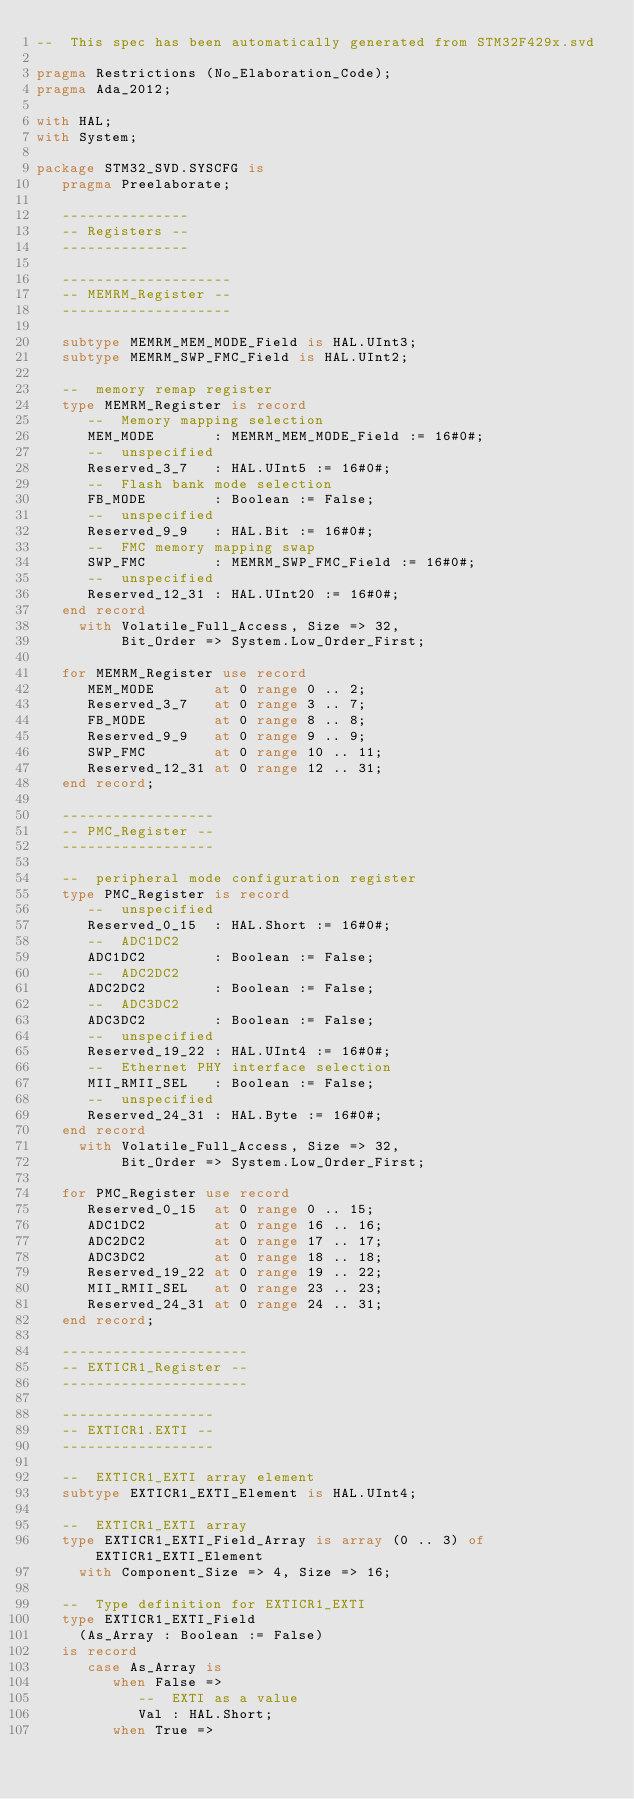Convert code to text. <code><loc_0><loc_0><loc_500><loc_500><_Ada_>--  This spec has been automatically generated from STM32F429x.svd

pragma Restrictions (No_Elaboration_Code);
pragma Ada_2012;

with HAL;
with System;

package STM32_SVD.SYSCFG is
   pragma Preelaborate;

   ---------------
   -- Registers --
   ---------------

   --------------------
   -- MEMRM_Register --
   --------------------

   subtype MEMRM_MEM_MODE_Field is HAL.UInt3;
   subtype MEMRM_SWP_FMC_Field is HAL.UInt2;

   --  memory remap register
   type MEMRM_Register is record
      --  Memory mapping selection
      MEM_MODE       : MEMRM_MEM_MODE_Field := 16#0#;
      --  unspecified
      Reserved_3_7   : HAL.UInt5 := 16#0#;
      --  Flash bank mode selection
      FB_MODE        : Boolean := False;
      --  unspecified
      Reserved_9_9   : HAL.Bit := 16#0#;
      --  FMC memory mapping swap
      SWP_FMC        : MEMRM_SWP_FMC_Field := 16#0#;
      --  unspecified
      Reserved_12_31 : HAL.UInt20 := 16#0#;
   end record
     with Volatile_Full_Access, Size => 32,
          Bit_Order => System.Low_Order_First;

   for MEMRM_Register use record
      MEM_MODE       at 0 range 0 .. 2;
      Reserved_3_7   at 0 range 3 .. 7;
      FB_MODE        at 0 range 8 .. 8;
      Reserved_9_9   at 0 range 9 .. 9;
      SWP_FMC        at 0 range 10 .. 11;
      Reserved_12_31 at 0 range 12 .. 31;
   end record;

   ------------------
   -- PMC_Register --
   ------------------

   --  peripheral mode configuration register
   type PMC_Register is record
      --  unspecified
      Reserved_0_15  : HAL.Short := 16#0#;
      --  ADC1DC2
      ADC1DC2        : Boolean := False;
      --  ADC2DC2
      ADC2DC2        : Boolean := False;
      --  ADC3DC2
      ADC3DC2        : Boolean := False;
      --  unspecified
      Reserved_19_22 : HAL.UInt4 := 16#0#;
      --  Ethernet PHY interface selection
      MII_RMII_SEL   : Boolean := False;
      --  unspecified
      Reserved_24_31 : HAL.Byte := 16#0#;
   end record
     with Volatile_Full_Access, Size => 32,
          Bit_Order => System.Low_Order_First;

   for PMC_Register use record
      Reserved_0_15  at 0 range 0 .. 15;
      ADC1DC2        at 0 range 16 .. 16;
      ADC2DC2        at 0 range 17 .. 17;
      ADC3DC2        at 0 range 18 .. 18;
      Reserved_19_22 at 0 range 19 .. 22;
      MII_RMII_SEL   at 0 range 23 .. 23;
      Reserved_24_31 at 0 range 24 .. 31;
   end record;

   ----------------------
   -- EXTICR1_Register --
   ----------------------

   ------------------
   -- EXTICR1.EXTI --
   ------------------

   --  EXTICR1_EXTI array element
   subtype EXTICR1_EXTI_Element is HAL.UInt4;

   --  EXTICR1_EXTI array
   type EXTICR1_EXTI_Field_Array is array (0 .. 3) of EXTICR1_EXTI_Element
     with Component_Size => 4, Size => 16;

   --  Type definition for EXTICR1_EXTI
   type EXTICR1_EXTI_Field
     (As_Array : Boolean := False)
   is record
      case As_Array is
         when False =>
            --  EXTI as a value
            Val : HAL.Short;
         when True =></code> 